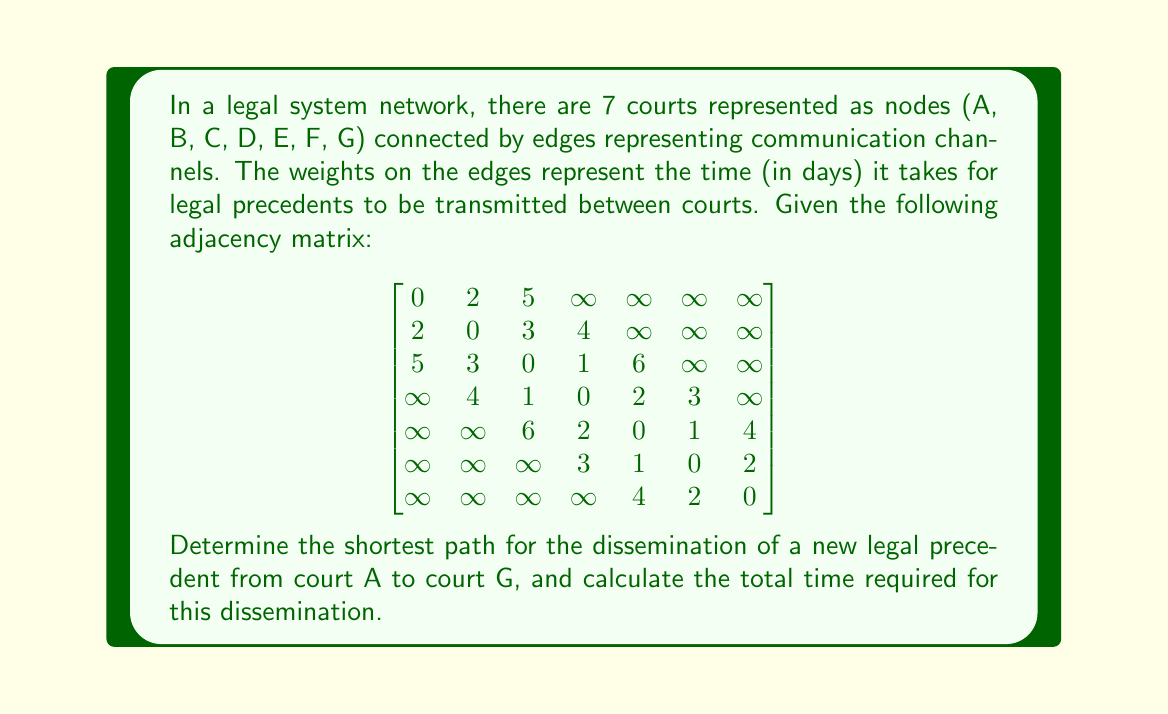What is the answer to this math problem? To solve this problem, we'll use Dijkstra's algorithm to find the shortest path from court A to court G in the given network.

Step 1: Initialize distances and previous nodes
- Set distance to A as 0 and all other distances as infinity
- Set all previous nodes as undefined

Step 2: Create a set of unvisited nodes containing all nodes

Step 3: For the current node (starting with A), consider all unvisited neighbors and calculate their tentative distances
- Update the neighbor's distance if the calculated distance is less than the previously recorded distance
- Update the previous node for the neighbor

Step 4: Mark the current node as visited and remove it from the unvisited set

Step 5: If the destination node (G) has been marked visited, we're done. Otherwise, select the unvisited node with the smallest tentative distance and go back to step 3

Following these steps, we get:

1. A -> B (2 days)
2. B -> C (3 days, total 5 days)
3. C -> D (1 day, total 6 days)
4. D -> E (2 days, total 8 days)
5. E -> F (1 day, total 9 days)
6. F -> G (2 days, total 11 days)

The shortest path is A -> B -> C -> D -> E -> F -> G, with a total time of 11 days.
Answer: The shortest path for dissemination of the legal precedent from court A to court G is A -> B -> C -> D -> E -> F -> G, and the total time required for this dissemination is 11 days. 